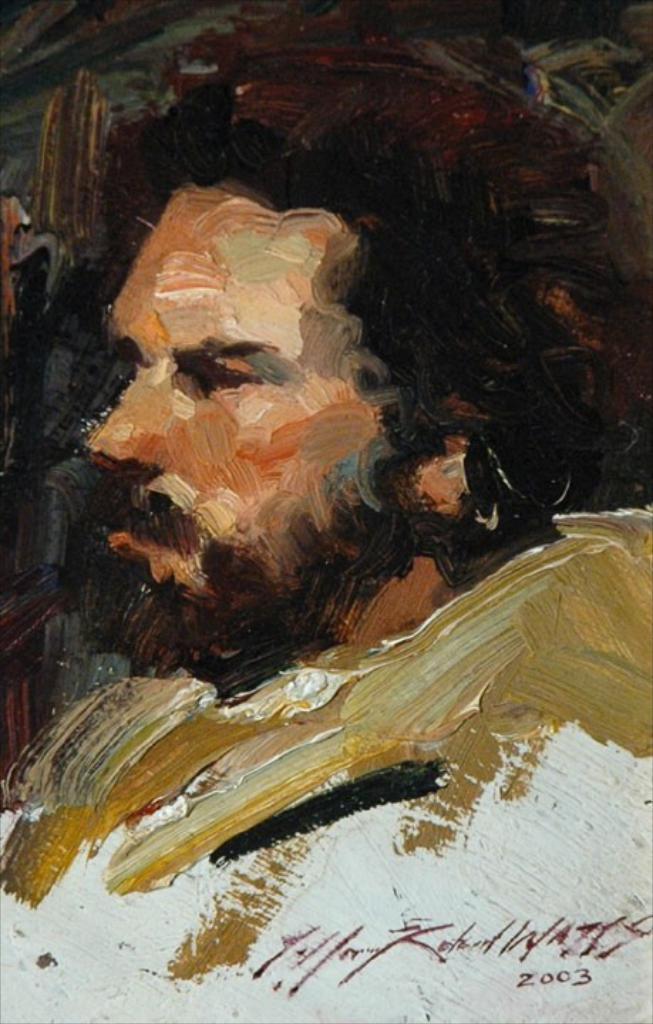In one or two sentences, can you explain what this image depicts? In the center of the image there is a man's painting. 